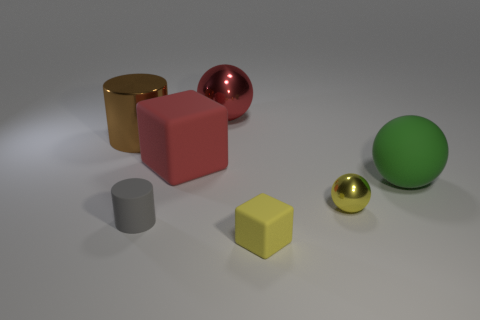Add 3 big green rubber spheres. How many objects exist? 10 Subtract all blocks. How many objects are left? 5 Subtract all rubber blocks. Subtract all tiny yellow objects. How many objects are left? 3 Add 6 brown cylinders. How many brown cylinders are left? 7 Add 4 brown metallic objects. How many brown metallic objects exist? 5 Subtract 0 blue cylinders. How many objects are left? 7 